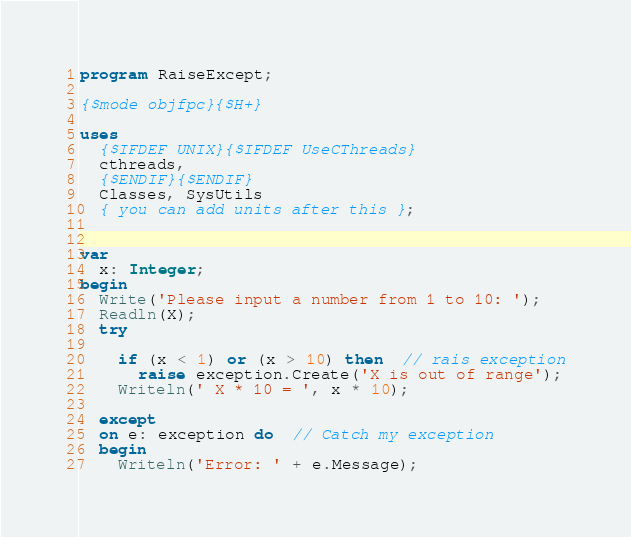<code> <loc_0><loc_0><loc_500><loc_500><_Pascal_>program RaiseExcept;

{$mode objfpc}{$H+}

uses
  {$IFDEF UNIX}{$IFDEF UseCThreads}
  cthreads,
  {$ENDIF}{$ENDIF}
  Classes, SysUtils
  { you can add units after this };


var
  x: Integer;
begin
  Write('Please input a number from 1 to 10: ');
  Readln(X);
  try

    if (x < 1) or (x > 10) then  // rais exception
      raise exception.Create('X is out of range');
    Writeln(' X * 10 = ', x * 10);

  except
  on e: exception do  // Catch my exception
  begin
    Writeln('Error: ' + e.Message);</code> 